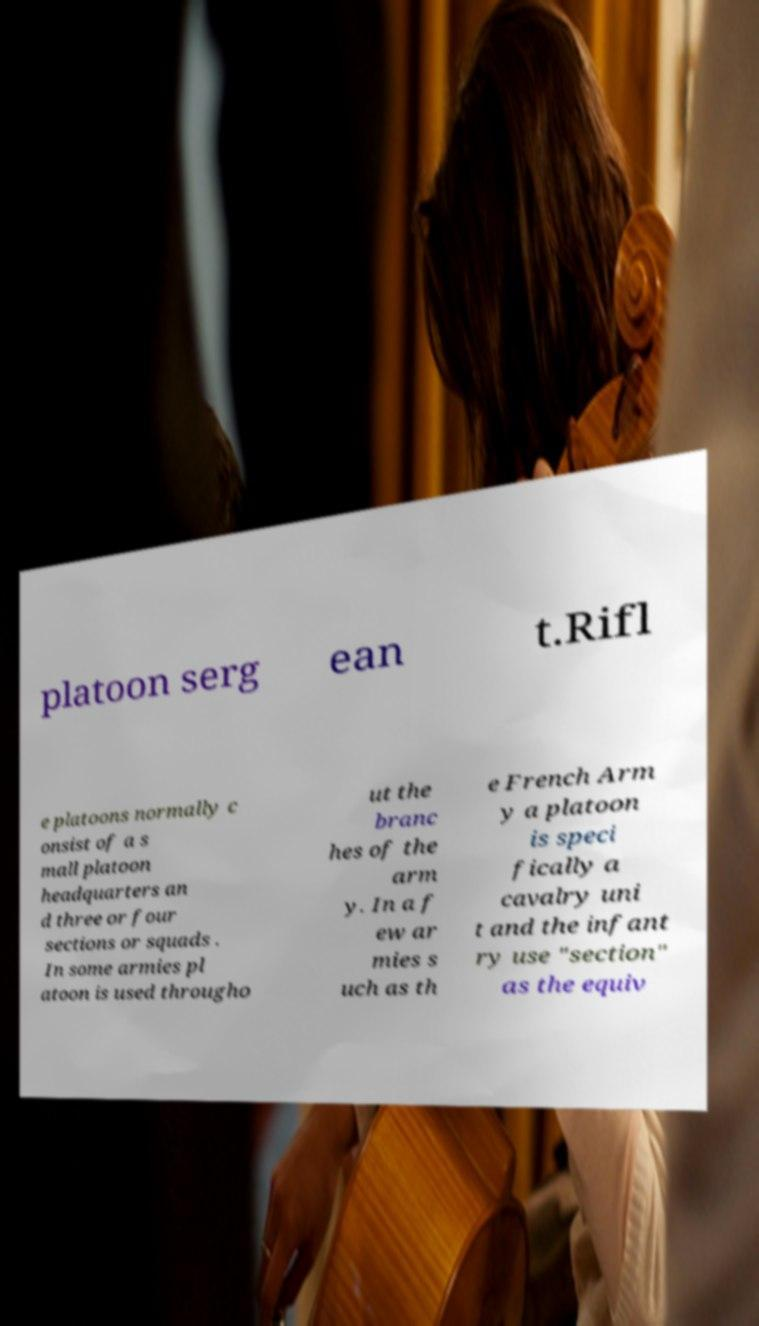Can you read and provide the text displayed in the image?This photo seems to have some interesting text. Can you extract and type it out for me? platoon serg ean t.Rifl e platoons normally c onsist of a s mall platoon headquarters an d three or four sections or squads . In some armies pl atoon is used througho ut the branc hes of the arm y. In a f ew ar mies s uch as th e French Arm y a platoon is speci fically a cavalry uni t and the infant ry use "section" as the equiv 